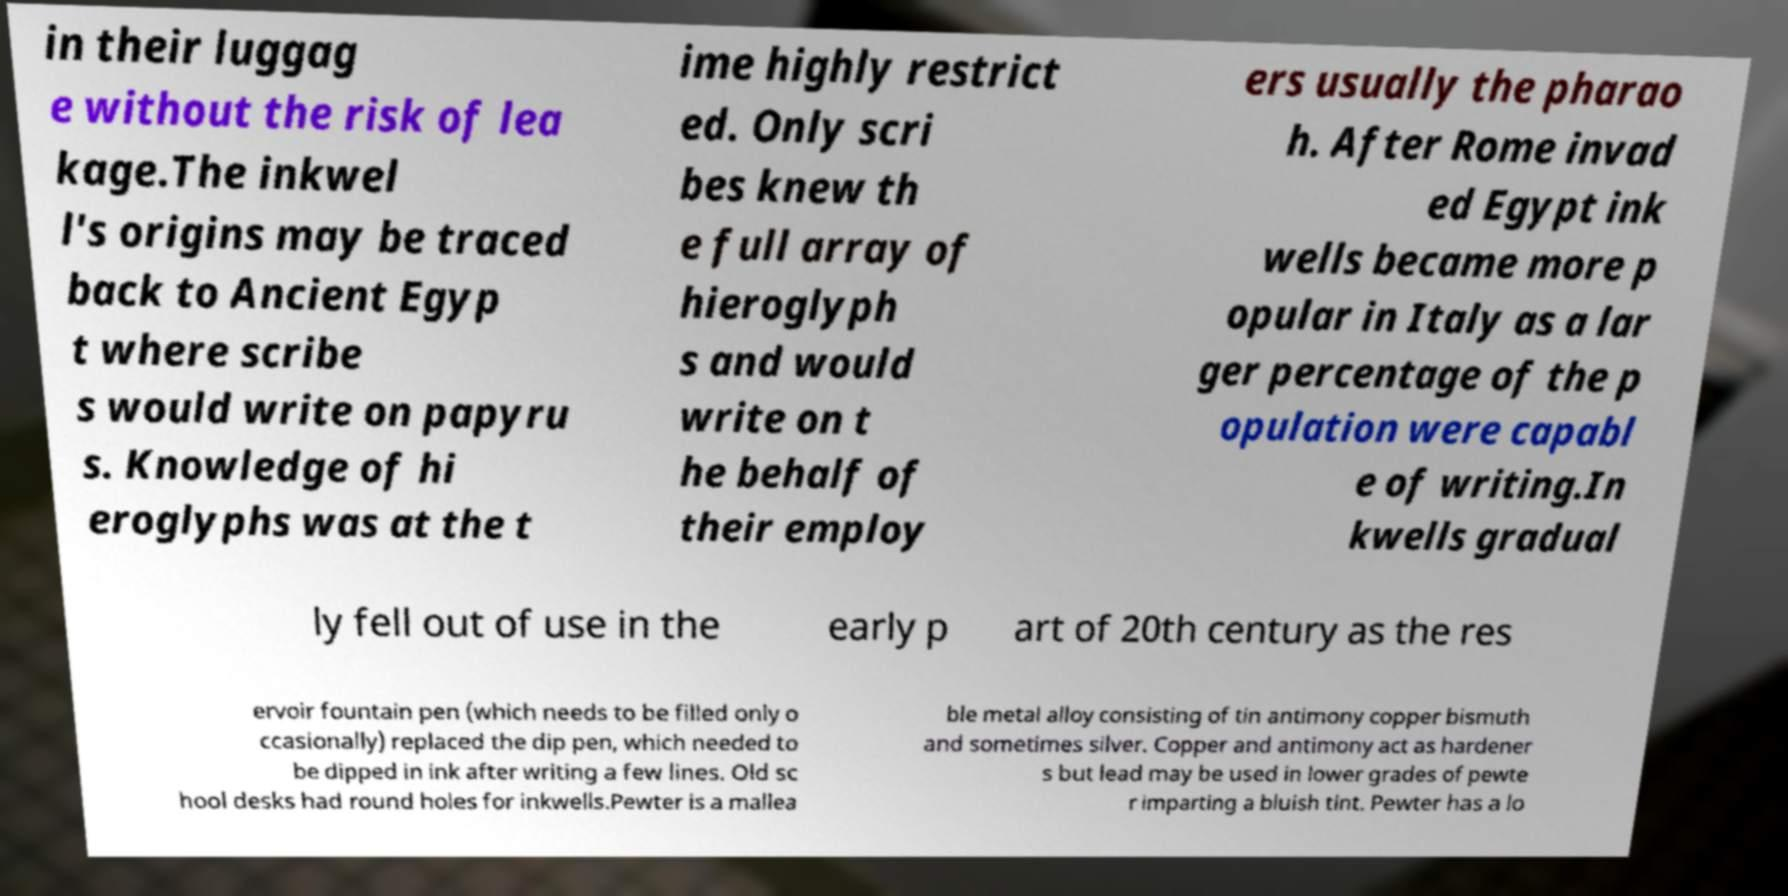What messages or text are displayed in this image? I need them in a readable, typed format. in their luggag e without the risk of lea kage.The inkwel l's origins may be traced back to Ancient Egyp t where scribe s would write on papyru s. Knowledge of hi eroglyphs was at the t ime highly restrict ed. Only scri bes knew th e full array of hieroglyph s and would write on t he behalf of their employ ers usually the pharao h. After Rome invad ed Egypt ink wells became more p opular in Italy as a lar ger percentage of the p opulation were capabl e of writing.In kwells gradual ly fell out of use in the early p art of 20th century as the res ervoir fountain pen (which needs to be filled only o ccasionally) replaced the dip pen, which needed to be dipped in ink after writing a few lines. Old sc hool desks had round holes for inkwells.Pewter is a mallea ble metal alloy consisting of tin antimony copper bismuth and sometimes silver. Copper and antimony act as hardener s but lead may be used in lower grades of pewte r imparting a bluish tint. Pewter has a lo 